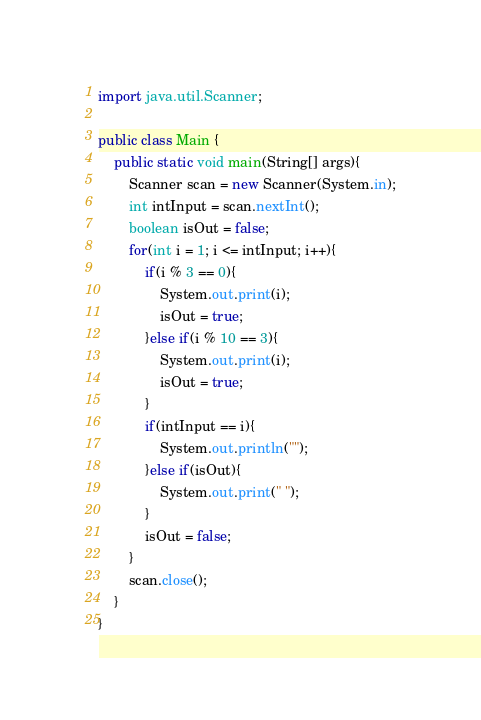Convert code to text. <code><loc_0><loc_0><loc_500><loc_500><_Java_>import java.util.Scanner;

public class Main {
	public static void main(String[] args){
		Scanner scan = new Scanner(System.in);
		int intInput = scan.nextInt();
		boolean isOut = false;
		for(int i = 1; i <= intInput; i++){
			if(i % 3 == 0){
				System.out.print(i);
				isOut = true;
			}else if(i % 10 == 3){
				System.out.print(i);
				isOut = true;
			}
			if(intInput == i){
				System.out.println("");
			}else if(isOut){
				System.out.print(" ");
			}
			isOut = false;
		}
		scan.close();
	}
}</code> 